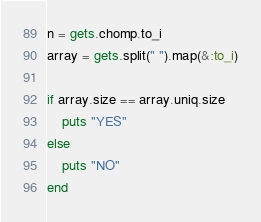<code> <loc_0><loc_0><loc_500><loc_500><_Ruby_>n = gets.chomp.to_i
array = gets.split(" ").map(&:to_i)

if array.size == array.uniq.size
    puts "YES"
else
    puts "NO"
end</code> 